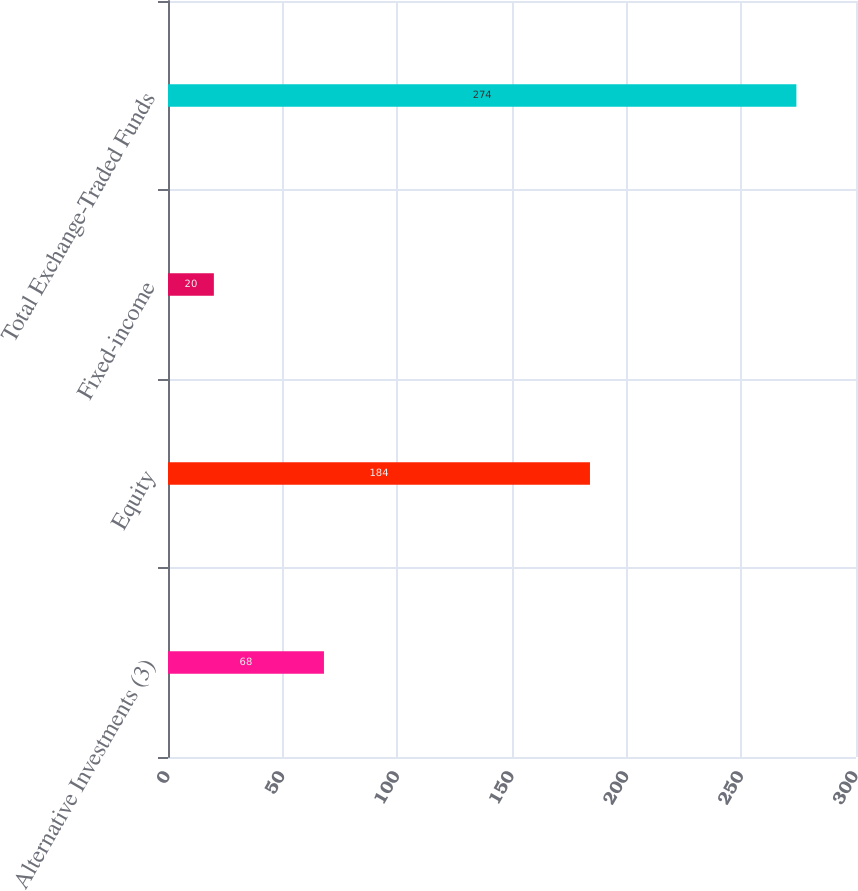Convert chart. <chart><loc_0><loc_0><loc_500><loc_500><bar_chart><fcel>Alternative Investments (3)<fcel>Equity<fcel>Fixed-income<fcel>Total Exchange-Traded Funds<nl><fcel>68<fcel>184<fcel>20<fcel>274<nl></chart> 